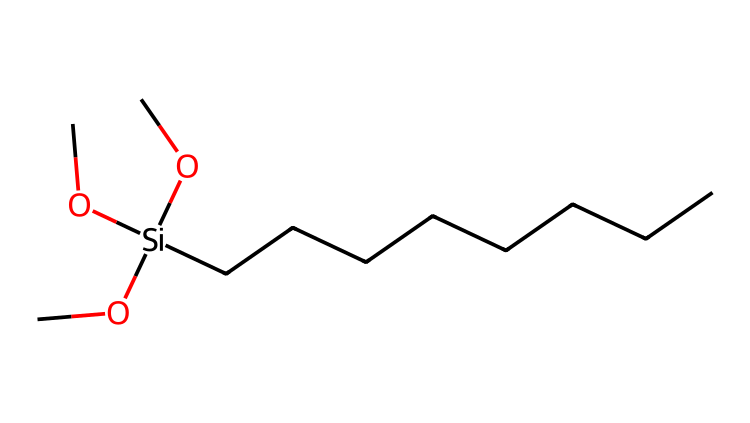What is the primary element in the chemical structure? The primary element visible in the SMILES representation is silicon, as indicated by the '[Si]' notation, which denotes the presence of a silicon atom in the molecule.
Answer: silicon How many carbon atoms are present in the structure? By analyzing the "CCCCCCCC" portion of the SMILES, we count eight 'C' characters, which signifies the presence of eight carbon atoms in the structure.
Answer: eight What type of bonding characterizes this silane? The structure shows single bonds between silicon and the carbon atoms as well as the alkoxy groups (OC), indicating that the bonding is covalent, which is typical for silanes.
Answer: covalent What is the total number of oxygen atoms in this silane? The "OC" portions dictate that there are three individual 'O' characters, leading us to conclude that there are three oxygen atoms present in the structure.
Answer: three What functional groups are present in this silane? The presence of "OC" (alkoxy groups) connected to the silicon atom indicates that the functional groups are alkoxy functional groups, which are responsible for its waterproofing properties.
Answer: alkoxy How many total atoms are in this silane molecule? Counting the atoms: 8 carbons, 3 oxygens, and 1 silicon gives us a total of 12 atoms in this molecule. We add them to reach the final total.
Answer: twelve 